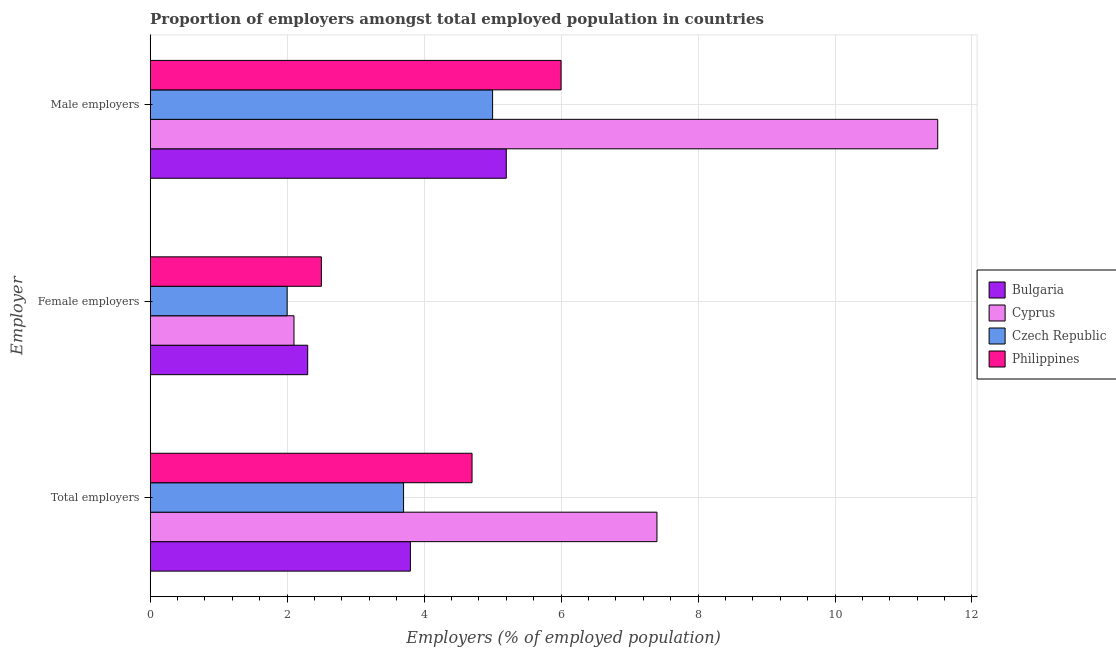How many different coloured bars are there?
Give a very brief answer. 4. How many groups of bars are there?
Give a very brief answer. 3. How many bars are there on the 1st tick from the top?
Provide a short and direct response. 4. How many bars are there on the 2nd tick from the bottom?
Give a very brief answer. 4. What is the label of the 2nd group of bars from the top?
Make the answer very short. Female employers. What is the percentage of male employers in Bulgaria?
Give a very brief answer. 5.2. Across all countries, what is the maximum percentage of female employers?
Make the answer very short. 2.5. Across all countries, what is the minimum percentage of male employers?
Your answer should be compact. 5. In which country was the percentage of total employers maximum?
Your answer should be very brief. Cyprus. In which country was the percentage of female employers minimum?
Offer a very short reply. Czech Republic. What is the total percentage of male employers in the graph?
Your response must be concise. 27.7. What is the difference between the percentage of female employers in Cyprus and the percentage of total employers in Philippines?
Your response must be concise. -2.6. What is the average percentage of male employers per country?
Provide a short and direct response. 6.92. What is the ratio of the percentage of female employers in Cyprus to that in Philippines?
Give a very brief answer. 0.84. What is the difference between the highest and the second highest percentage of female employers?
Offer a very short reply. 0.2. What is the difference between the highest and the lowest percentage of total employers?
Make the answer very short. 3.7. Is the sum of the percentage of female employers in Philippines and Czech Republic greater than the maximum percentage of male employers across all countries?
Your answer should be very brief. No. What does the 3rd bar from the top in Male employers represents?
Offer a terse response. Cyprus. What does the 4th bar from the bottom in Total employers represents?
Your response must be concise. Philippines. How many bars are there?
Make the answer very short. 12. Are all the bars in the graph horizontal?
Ensure brevity in your answer.  Yes. How many countries are there in the graph?
Your answer should be very brief. 4. What is the difference between two consecutive major ticks on the X-axis?
Ensure brevity in your answer.  2. Does the graph contain any zero values?
Offer a very short reply. No. Where does the legend appear in the graph?
Provide a short and direct response. Center right. How many legend labels are there?
Your response must be concise. 4. What is the title of the graph?
Provide a short and direct response. Proportion of employers amongst total employed population in countries. Does "Mongolia" appear as one of the legend labels in the graph?
Ensure brevity in your answer.  No. What is the label or title of the X-axis?
Ensure brevity in your answer.  Employers (% of employed population). What is the label or title of the Y-axis?
Offer a very short reply. Employer. What is the Employers (% of employed population) of Bulgaria in Total employers?
Provide a succinct answer. 3.8. What is the Employers (% of employed population) of Cyprus in Total employers?
Your answer should be compact. 7.4. What is the Employers (% of employed population) in Czech Republic in Total employers?
Offer a terse response. 3.7. What is the Employers (% of employed population) in Philippines in Total employers?
Provide a short and direct response. 4.7. What is the Employers (% of employed population) of Bulgaria in Female employers?
Provide a short and direct response. 2.3. What is the Employers (% of employed population) in Cyprus in Female employers?
Ensure brevity in your answer.  2.1. What is the Employers (% of employed population) in Bulgaria in Male employers?
Your response must be concise. 5.2. What is the Employers (% of employed population) in Cyprus in Male employers?
Offer a terse response. 11.5. What is the Employers (% of employed population) of Czech Republic in Male employers?
Provide a short and direct response. 5. Across all Employer, what is the maximum Employers (% of employed population) in Bulgaria?
Ensure brevity in your answer.  5.2. Across all Employer, what is the maximum Employers (% of employed population) in Cyprus?
Your answer should be compact. 11.5. Across all Employer, what is the minimum Employers (% of employed population) in Bulgaria?
Your answer should be compact. 2.3. Across all Employer, what is the minimum Employers (% of employed population) of Cyprus?
Make the answer very short. 2.1. Across all Employer, what is the minimum Employers (% of employed population) in Philippines?
Give a very brief answer. 2.5. What is the total Employers (% of employed population) of Bulgaria in the graph?
Your response must be concise. 11.3. What is the total Employers (% of employed population) of Cyprus in the graph?
Your answer should be very brief. 21. What is the total Employers (% of employed population) of Philippines in the graph?
Provide a succinct answer. 13.2. What is the difference between the Employers (% of employed population) of Bulgaria in Total employers and that in Female employers?
Offer a terse response. 1.5. What is the difference between the Employers (% of employed population) of Cyprus in Total employers and that in Female employers?
Offer a terse response. 5.3. What is the difference between the Employers (% of employed population) of Bulgaria in Total employers and that in Male employers?
Give a very brief answer. -1.4. What is the difference between the Employers (% of employed population) in Czech Republic in Total employers and that in Male employers?
Make the answer very short. -1.3. What is the difference between the Employers (% of employed population) of Bulgaria in Total employers and the Employers (% of employed population) of Czech Republic in Female employers?
Your response must be concise. 1.8. What is the difference between the Employers (% of employed population) in Cyprus in Total employers and the Employers (% of employed population) in Czech Republic in Female employers?
Ensure brevity in your answer.  5.4. What is the difference between the Employers (% of employed population) of Cyprus in Total employers and the Employers (% of employed population) of Philippines in Female employers?
Your answer should be very brief. 4.9. What is the difference between the Employers (% of employed population) in Czech Republic in Total employers and the Employers (% of employed population) in Philippines in Female employers?
Provide a succinct answer. 1.2. What is the difference between the Employers (% of employed population) in Bulgaria in Total employers and the Employers (% of employed population) in Cyprus in Male employers?
Keep it short and to the point. -7.7. What is the difference between the Employers (% of employed population) in Bulgaria in Total employers and the Employers (% of employed population) in Philippines in Male employers?
Provide a succinct answer. -2.2. What is the difference between the Employers (% of employed population) in Cyprus in Total employers and the Employers (% of employed population) in Philippines in Male employers?
Offer a terse response. 1.4. What is the difference between the Employers (% of employed population) of Bulgaria in Female employers and the Employers (% of employed population) of Cyprus in Male employers?
Offer a terse response. -9.2. What is the difference between the Employers (% of employed population) in Cyprus in Female employers and the Employers (% of employed population) in Czech Republic in Male employers?
Offer a terse response. -2.9. What is the average Employers (% of employed population) in Bulgaria per Employer?
Provide a short and direct response. 3.77. What is the average Employers (% of employed population) in Cyprus per Employer?
Give a very brief answer. 7. What is the average Employers (% of employed population) in Czech Republic per Employer?
Offer a terse response. 3.57. What is the difference between the Employers (% of employed population) of Bulgaria and Employers (% of employed population) of Cyprus in Total employers?
Your answer should be compact. -3.6. What is the difference between the Employers (% of employed population) in Bulgaria and Employers (% of employed population) in Philippines in Total employers?
Your answer should be very brief. -0.9. What is the difference between the Employers (% of employed population) of Cyprus and Employers (% of employed population) of Czech Republic in Total employers?
Provide a short and direct response. 3.7. What is the difference between the Employers (% of employed population) of Czech Republic and Employers (% of employed population) of Philippines in Total employers?
Make the answer very short. -1. What is the difference between the Employers (% of employed population) in Bulgaria and Employers (% of employed population) in Cyprus in Female employers?
Make the answer very short. 0.2. What is the difference between the Employers (% of employed population) in Bulgaria and Employers (% of employed population) in Philippines in Female employers?
Your response must be concise. -0.2. What is the difference between the Employers (% of employed population) in Bulgaria and Employers (% of employed population) in Cyprus in Male employers?
Ensure brevity in your answer.  -6.3. What is the difference between the Employers (% of employed population) in Bulgaria and Employers (% of employed population) in Philippines in Male employers?
Offer a terse response. -0.8. What is the difference between the Employers (% of employed population) in Cyprus and Employers (% of employed population) in Czech Republic in Male employers?
Provide a succinct answer. 6.5. What is the difference between the Employers (% of employed population) of Czech Republic and Employers (% of employed population) of Philippines in Male employers?
Make the answer very short. -1. What is the ratio of the Employers (% of employed population) in Bulgaria in Total employers to that in Female employers?
Offer a terse response. 1.65. What is the ratio of the Employers (% of employed population) in Cyprus in Total employers to that in Female employers?
Keep it short and to the point. 3.52. What is the ratio of the Employers (% of employed population) in Czech Republic in Total employers to that in Female employers?
Offer a very short reply. 1.85. What is the ratio of the Employers (% of employed population) in Philippines in Total employers to that in Female employers?
Ensure brevity in your answer.  1.88. What is the ratio of the Employers (% of employed population) in Bulgaria in Total employers to that in Male employers?
Offer a very short reply. 0.73. What is the ratio of the Employers (% of employed population) in Cyprus in Total employers to that in Male employers?
Make the answer very short. 0.64. What is the ratio of the Employers (% of employed population) in Czech Republic in Total employers to that in Male employers?
Give a very brief answer. 0.74. What is the ratio of the Employers (% of employed population) of Philippines in Total employers to that in Male employers?
Keep it short and to the point. 0.78. What is the ratio of the Employers (% of employed population) of Bulgaria in Female employers to that in Male employers?
Provide a succinct answer. 0.44. What is the ratio of the Employers (% of employed population) in Cyprus in Female employers to that in Male employers?
Offer a terse response. 0.18. What is the ratio of the Employers (% of employed population) of Philippines in Female employers to that in Male employers?
Make the answer very short. 0.42. What is the difference between the highest and the second highest Employers (% of employed population) of Bulgaria?
Offer a terse response. 1.4. What is the difference between the highest and the second highest Employers (% of employed population) in Philippines?
Your answer should be very brief. 1.3. What is the difference between the highest and the lowest Employers (% of employed population) of Czech Republic?
Your answer should be very brief. 3. 